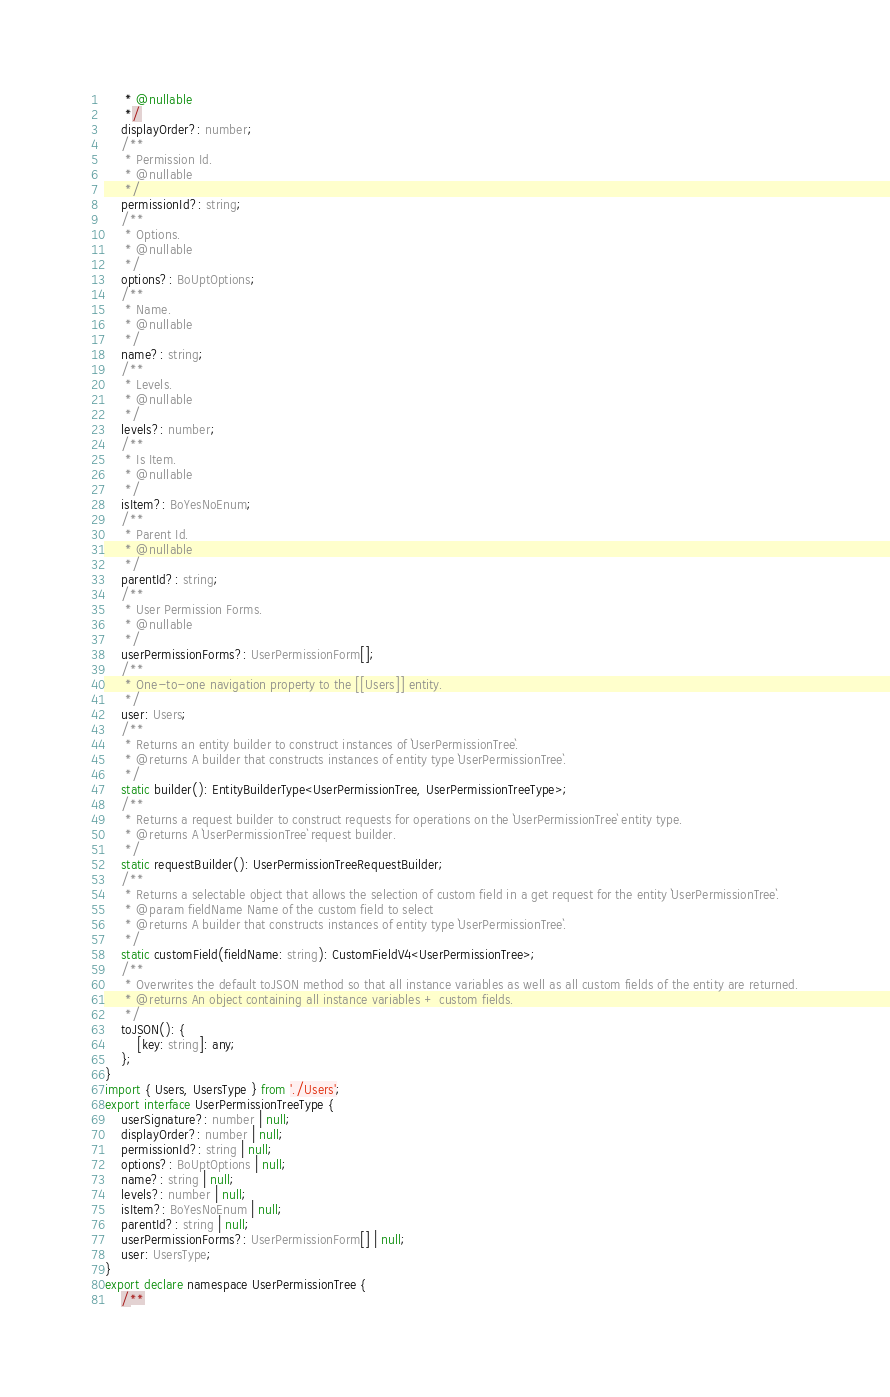<code> <loc_0><loc_0><loc_500><loc_500><_TypeScript_>     * @nullable
     */
    displayOrder?: number;
    /**
     * Permission Id.
     * @nullable
     */
    permissionId?: string;
    /**
     * Options.
     * @nullable
     */
    options?: BoUptOptions;
    /**
     * Name.
     * @nullable
     */
    name?: string;
    /**
     * Levels.
     * @nullable
     */
    levels?: number;
    /**
     * Is Item.
     * @nullable
     */
    isItem?: BoYesNoEnum;
    /**
     * Parent Id.
     * @nullable
     */
    parentId?: string;
    /**
     * User Permission Forms.
     * @nullable
     */
    userPermissionForms?: UserPermissionForm[];
    /**
     * One-to-one navigation property to the [[Users]] entity.
     */
    user: Users;
    /**
     * Returns an entity builder to construct instances of `UserPermissionTree`.
     * @returns A builder that constructs instances of entity type `UserPermissionTree`.
     */
    static builder(): EntityBuilderType<UserPermissionTree, UserPermissionTreeType>;
    /**
     * Returns a request builder to construct requests for operations on the `UserPermissionTree` entity type.
     * @returns A `UserPermissionTree` request builder.
     */
    static requestBuilder(): UserPermissionTreeRequestBuilder;
    /**
     * Returns a selectable object that allows the selection of custom field in a get request for the entity `UserPermissionTree`.
     * @param fieldName Name of the custom field to select
     * @returns A builder that constructs instances of entity type `UserPermissionTree`.
     */
    static customField(fieldName: string): CustomFieldV4<UserPermissionTree>;
    /**
     * Overwrites the default toJSON method so that all instance variables as well as all custom fields of the entity are returned.
     * @returns An object containing all instance variables + custom fields.
     */
    toJSON(): {
        [key: string]: any;
    };
}
import { Users, UsersType } from './Users';
export interface UserPermissionTreeType {
    userSignature?: number | null;
    displayOrder?: number | null;
    permissionId?: string | null;
    options?: BoUptOptions | null;
    name?: string | null;
    levels?: number | null;
    isItem?: BoYesNoEnum | null;
    parentId?: string | null;
    userPermissionForms?: UserPermissionForm[] | null;
    user: UsersType;
}
export declare namespace UserPermissionTree {
    /**</code> 